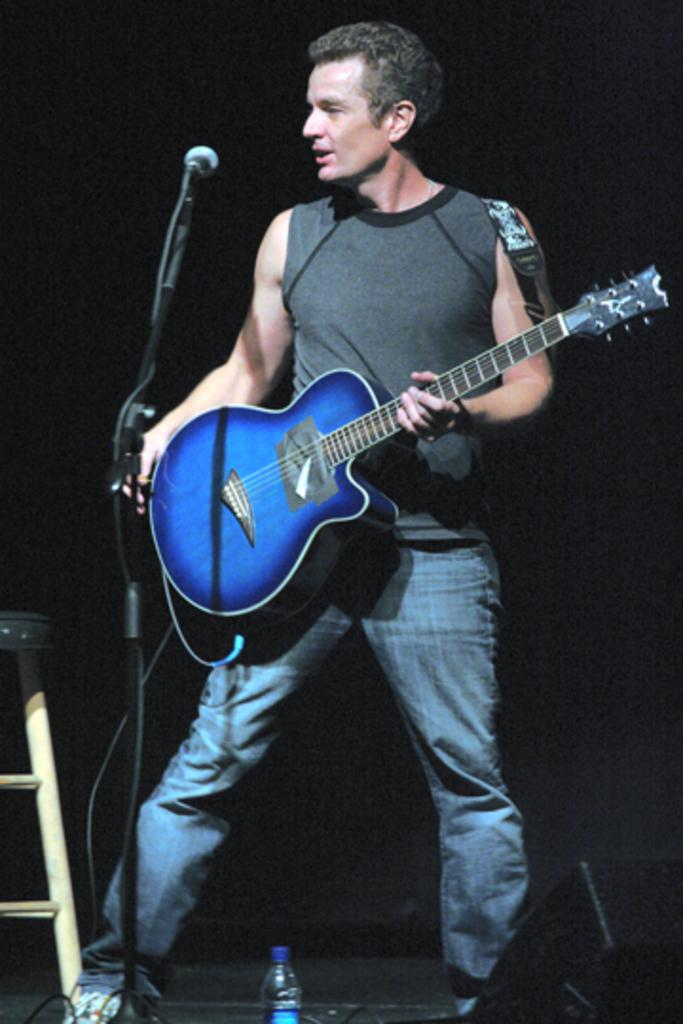What is the person in the image doing? The person is holding a guitar in the image. What other objects can be seen in the image? There is a microphone, a bottle, and a stool in the image. What is the color of the background in the image? The background of the image is dark. What is the texture of the heart in the image? There is no heart present in the image. How does the calculator help the person in the image? There is no calculator present in the image. 